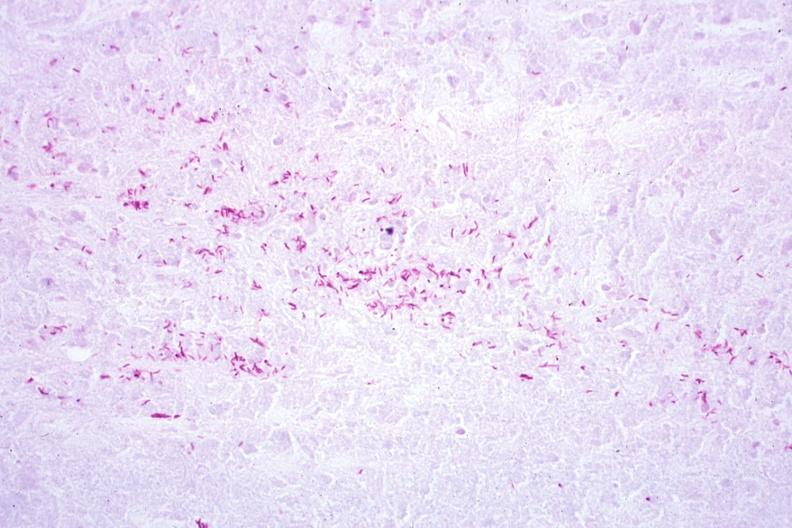does excellent example show acid fast stain a zillion organisms?
Answer the question using a single word or phrase. No 